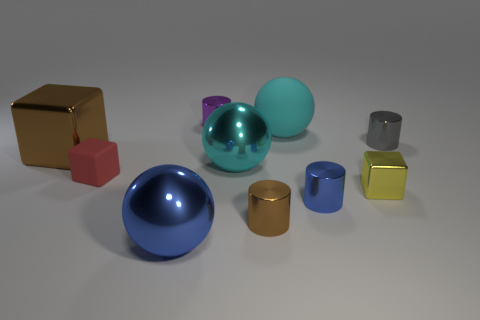There is a small gray thing behind the blue sphere; is its shape the same as the large rubber object?
Your answer should be compact. No. There is a blue metallic thing to the left of the purple metal object; what is its shape?
Your response must be concise. Sphere. There is a metallic object that is the same color as the big rubber thing; what shape is it?
Offer a terse response. Sphere. How many purple metal cylinders have the same size as the gray metal cylinder?
Offer a terse response. 1. What is the color of the tiny metallic cube?
Give a very brief answer. Yellow. There is a big shiny cube; does it have the same color as the sphere that is in front of the blue cylinder?
Provide a short and direct response. No. What is the size of the blue ball that is the same material as the small brown thing?
Your response must be concise. Large. Are there any metallic balls that have the same color as the small shiny cube?
Give a very brief answer. No. What number of objects are either small red cubes that are to the left of the brown cylinder or cylinders?
Make the answer very short. 5. Do the big blue sphere and the cyan object behind the big brown metallic cube have the same material?
Give a very brief answer. No. 